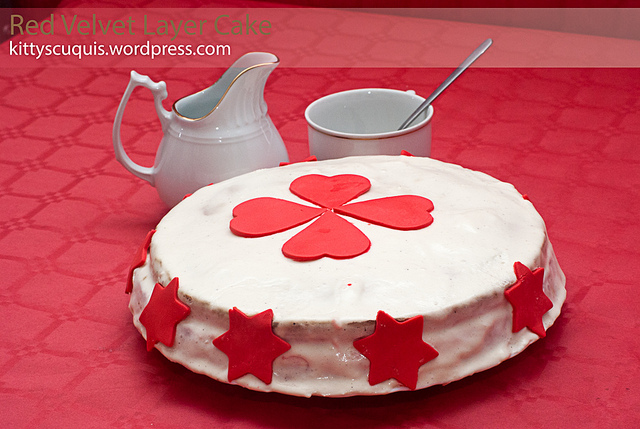Read and extract the text from this image. Red Velvet Layer Gale kittscuquis.wordpress.com 